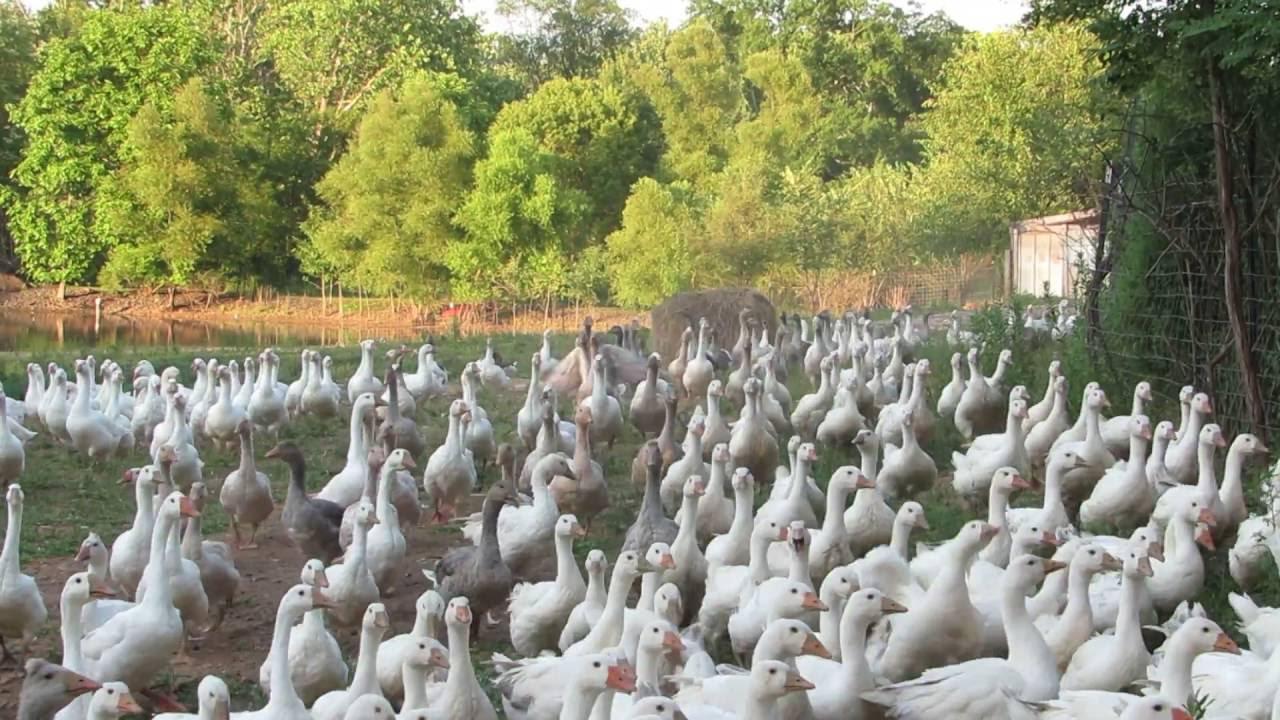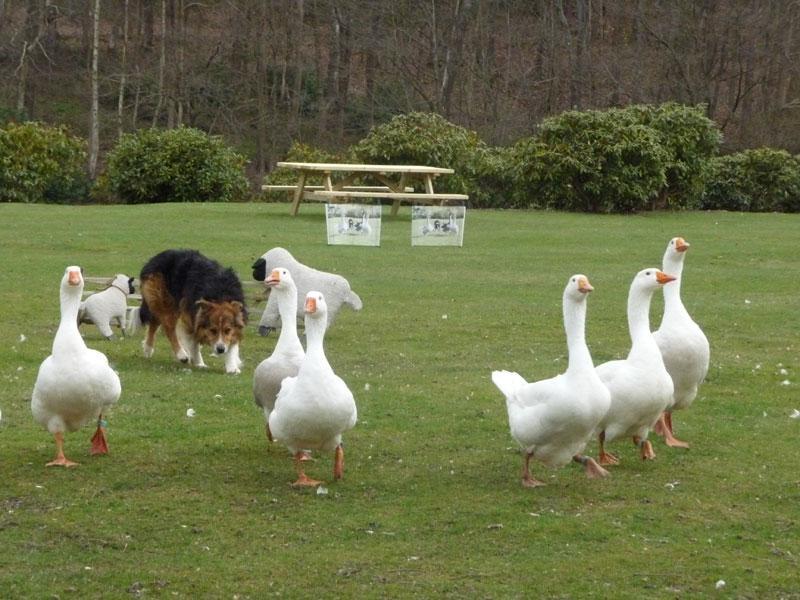The first image is the image on the left, the second image is the image on the right. Examine the images to the left and right. Is the description "One image shows a dog standing on grass behind a small flock of duck-like birds." accurate? Answer yes or no. Yes. The first image is the image on the left, the second image is the image on the right. Considering the images on both sides, is "A single woman is standing with birds in the image on the left." valid? Answer yes or no. No. 